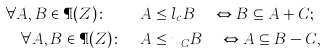<formula> <loc_0><loc_0><loc_500><loc_500>\forall A , B \in \P ( Z ) \colon \quad & A \leq l _ { c } B \quad \Leftrightarrow B \subseteq A + C ; \\ \forall A , B \in \P ( Z ) \colon \quad & A \leq u _ { C } B \quad \Leftrightarrow A \subseteq B - C ,</formula> 